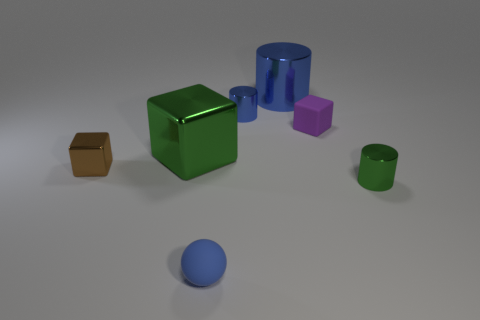Is the number of small things greater than the number of brown blocks?
Your response must be concise. Yes. What is the shape of the matte thing that is behind the tiny shiny thing that is to the right of the small purple cube?
Provide a succinct answer. Cube. Do the small matte ball and the matte cube have the same color?
Your response must be concise. No. Are there more matte cubes that are behind the big cylinder than small blue metallic things?
Provide a succinct answer. No. There is a green shiny object right of the green metal block; how many blue balls are behind it?
Your answer should be very brief. 0. Do the green object behind the tiny brown metal cube and the small thing behind the small rubber cube have the same material?
Your response must be concise. Yes. There is a small thing that is the same color as the ball; what is its material?
Ensure brevity in your answer.  Metal. What number of tiny brown objects have the same shape as the big green object?
Provide a succinct answer. 1. Is the big cube made of the same material as the small cylinder behind the tiny purple thing?
Your answer should be very brief. Yes. What material is the cylinder that is the same size as the green cube?
Make the answer very short. Metal. 